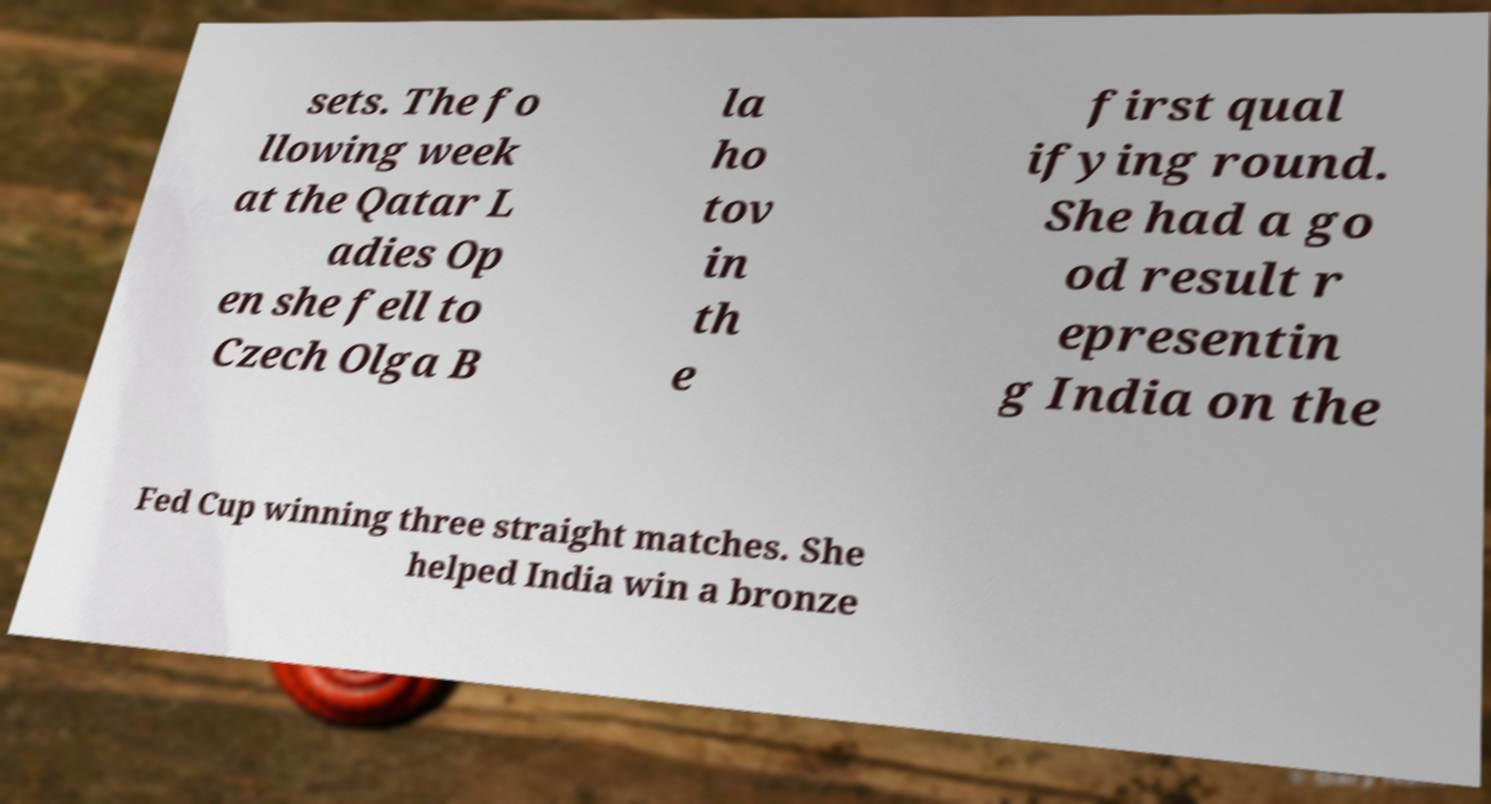Could you extract and type out the text from this image? sets. The fo llowing week at the Qatar L adies Op en she fell to Czech Olga B la ho tov in th e first qual ifying round. She had a go od result r epresentin g India on the Fed Cup winning three straight matches. She helped India win a bronze 